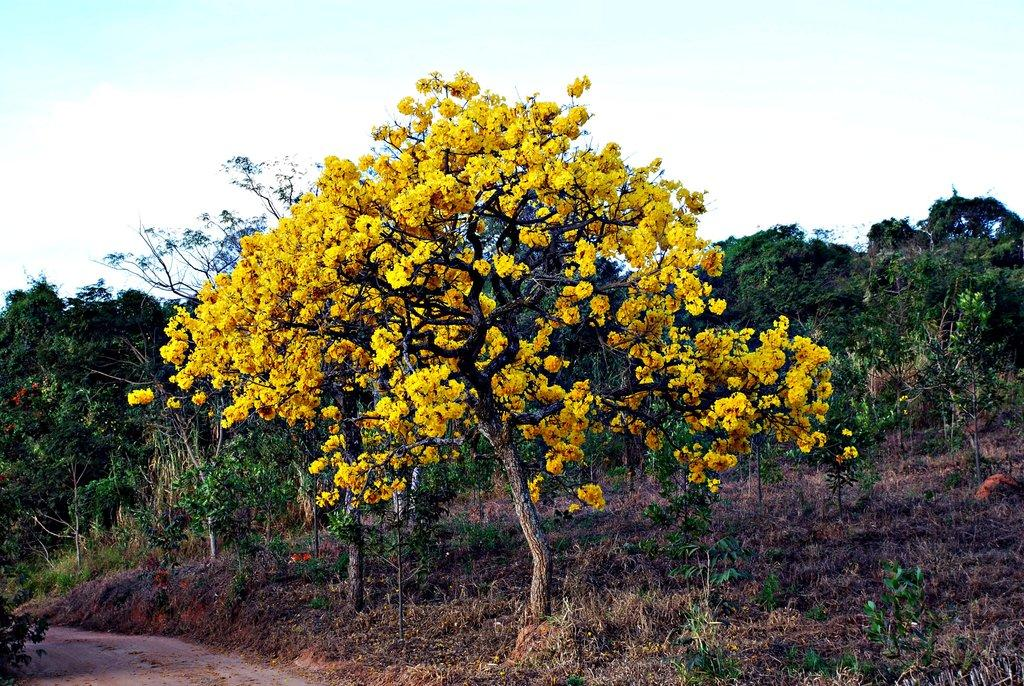What type of vegetation is present in the image? There are trees and grass in the image. Can you describe the ground in the image? There is a path on the bottom left side of the image. What can be seen in the background of the image? The sky is visible in the background of the image. Is there an umbrella being used by a toad in the image? There is no toad or umbrella present in the image. 